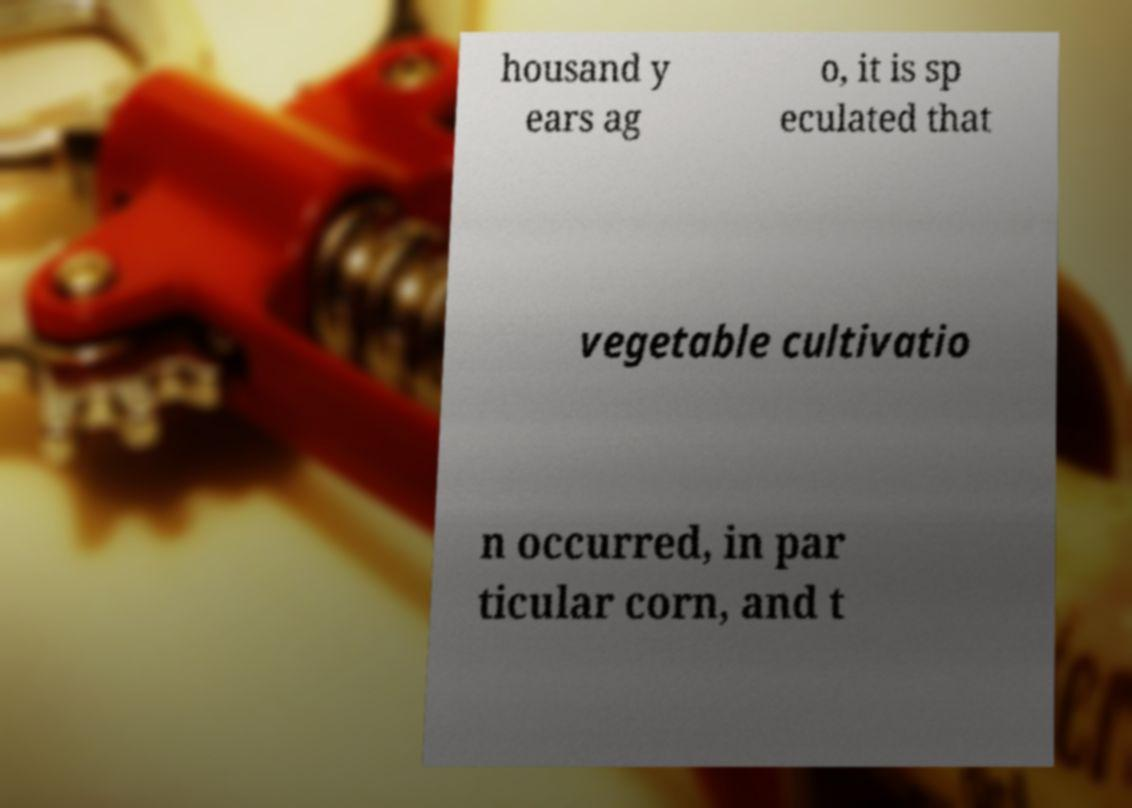Can you read and provide the text displayed in the image?This photo seems to have some interesting text. Can you extract and type it out for me? housand y ears ag o, it is sp eculated that vegetable cultivatio n occurred, in par ticular corn, and t 